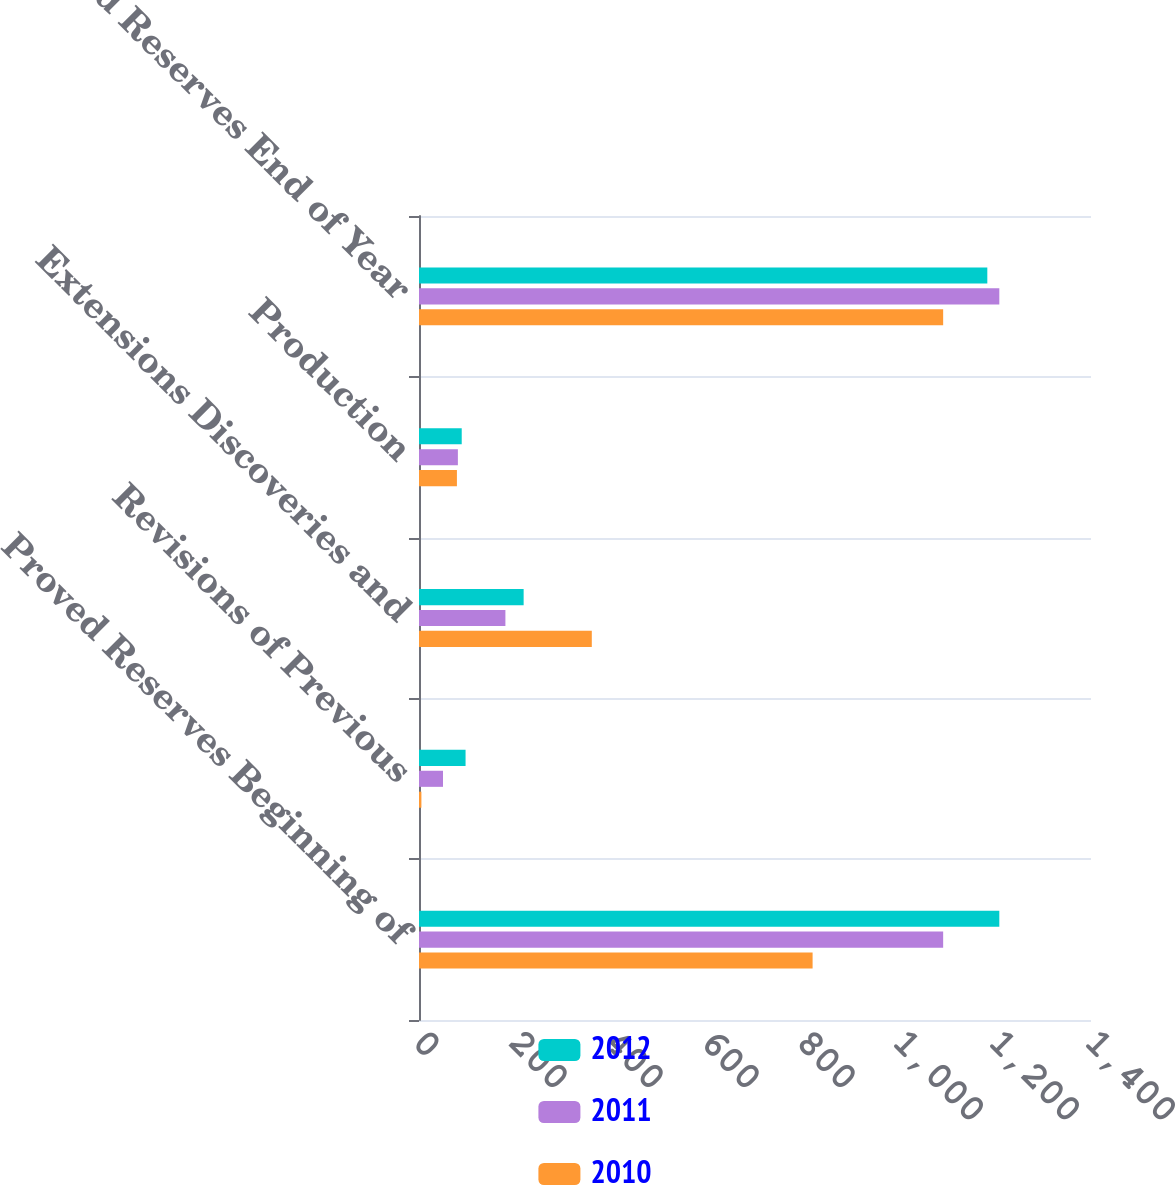<chart> <loc_0><loc_0><loc_500><loc_500><stacked_bar_chart><ecel><fcel>Proved Reserves Beginning of<fcel>Revisions of Previous<fcel>Extensions Discoveries and<fcel>Production<fcel>Proved Reserves End of Year<nl><fcel>2012<fcel>1209<fcel>97<fcel>218<fcel>89<fcel>1184<nl><fcel>2011<fcel>1092<fcel>50<fcel>180<fcel>81<fcel>1209<nl><fcel>2010<fcel>820<fcel>5<fcel>360<fcel>79<fcel>1092<nl></chart> 